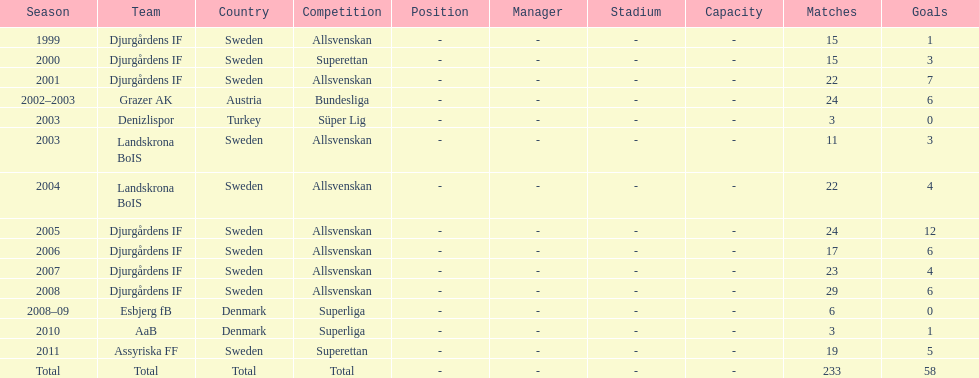What country is team djurgårdens if not from? Sweden. 